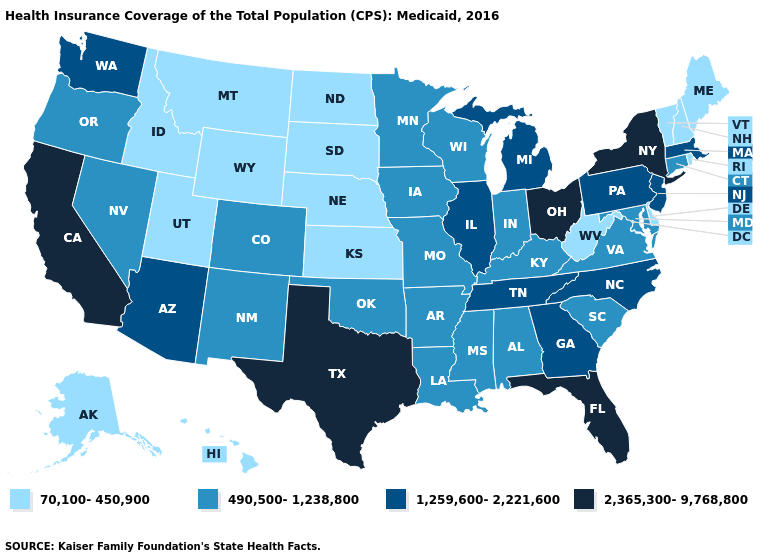Name the states that have a value in the range 490,500-1,238,800?
Write a very short answer. Alabama, Arkansas, Colorado, Connecticut, Indiana, Iowa, Kentucky, Louisiana, Maryland, Minnesota, Mississippi, Missouri, Nevada, New Mexico, Oklahoma, Oregon, South Carolina, Virginia, Wisconsin. Does North Dakota have the lowest value in the USA?
Keep it brief. Yes. Among the states that border Ohio , does West Virginia have the highest value?
Give a very brief answer. No. Does Kentucky have the lowest value in the USA?
Concise answer only. No. Name the states that have a value in the range 70,100-450,900?
Write a very short answer. Alaska, Delaware, Hawaii, Idaho, Kansas, Maine, Montana, Nebraska, New Hampshire, North Dakota, Rhode Island, South Dakota, Utah, Vermont, West Virginia, Wyoming. Among the states that border Wyoming , which have the lowest value?
Give a very brief answer. Idaho, Montana, Nebraska, South Dakota, Utah. What is the value of New Mexico?
Keep it brief. 490,500-1,238,800. What is the value of Arkansas?
Keep it brief. 490,500-1,238,800. Among the states that border New Jersey , which have the lowest value?
Give a very brief answer. Delaware. What is the value of Iowa?
Keep it brief. 490,500-1,238,800. What is the highest value in the South ?
Concise answer only. 2,365,300-9,768,800. What is the value of New Hampshire?
Short answer required. 70,100-450,900. Name the states that have a value in the range 490,500-1,238,800?
Concise answer only. Alabama, Arkansas, Colorado, Connecticut, Indiana, Iowa, Kentucky, Louisiana, Maryland, Minnesota, Mississippi, Missouri, Nevada, New Mexico, Oklahoma, Oregon, South Carolina, Virginia, Wisconsin. Does the map have missing data?
Short answer required. No. What is the value of Texas?
Answer briefly. 2,365,300-9,768,800. 